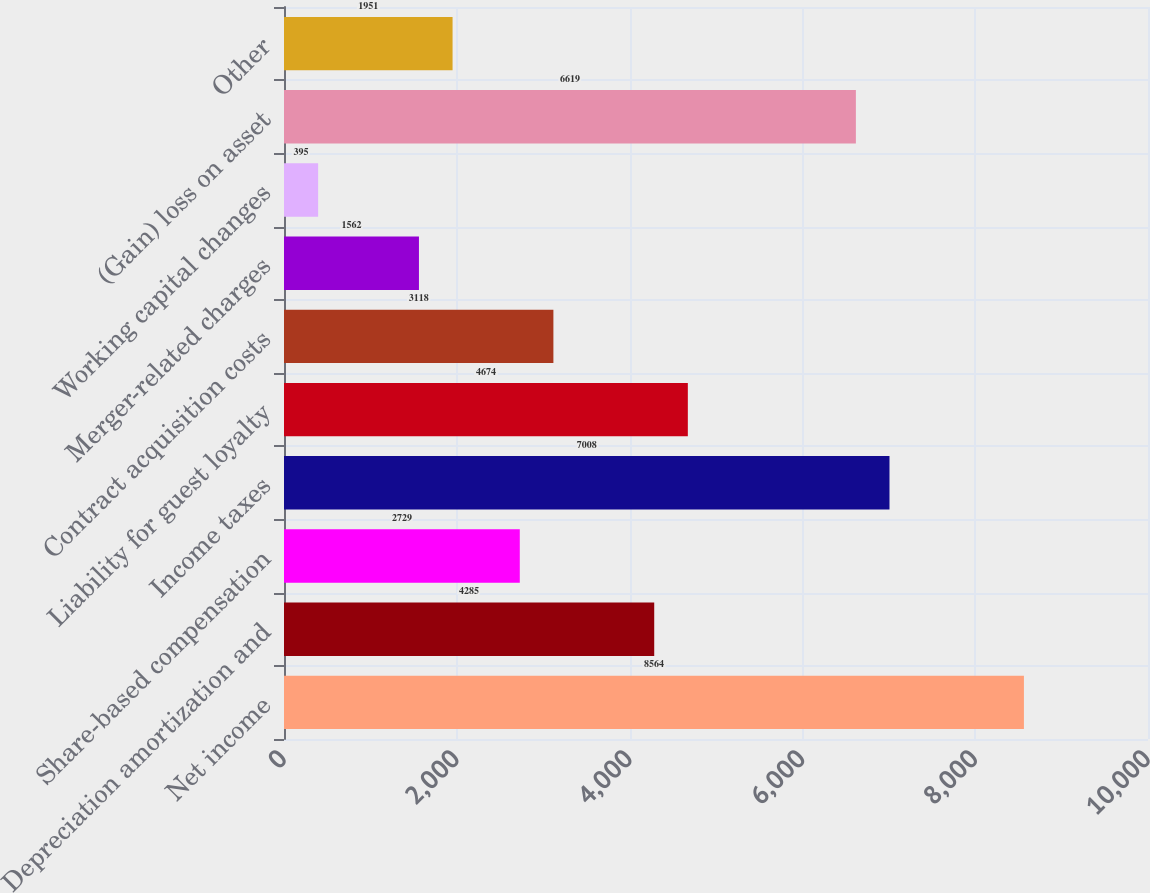Convert chart to OTSL. <chart><loc_0><loc_0><loc_500><loc_500><bar_chart><fcel>Net income<fcel>Depreciation amortization and<fcel>Share-based compensation<fcel>Income taxes<fcel>Liability for guest loyalty<fcel>Contract acquisition costs<fcel>Merger-related charges<fcel>Working capital changes<fcel>(Gain) loss on asset<fcel>Other<nl><fcel>8564<fcel>4285<fcel>2729<fcel>7008<fcel>4674<fcel>3118<fcel>1562<fcel>395<fcel>6619<fcel>1951<nl></chart> 